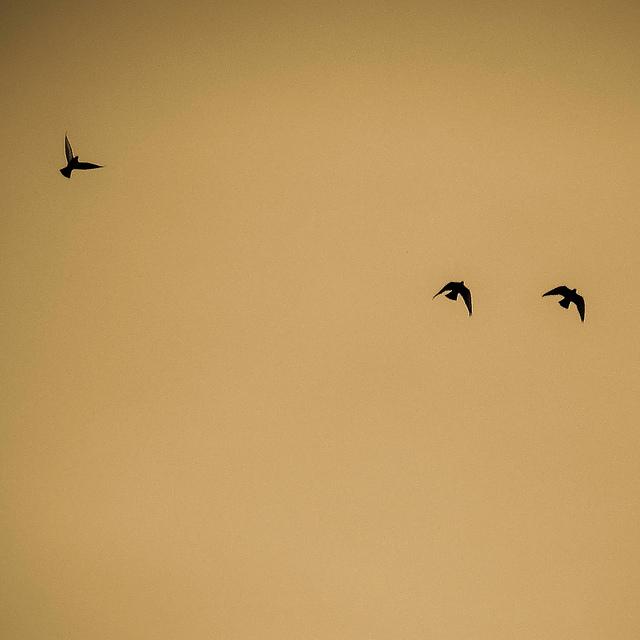What is flying in the air?
Answer briefly. Birds. How many birds are there?
Be succinct. 3. Are the birds wings open or closed?
Concise answer only. Open. Are there birds on the light post?
Concise answer only. No. Could this be synchronized flying?
Answer briefly. No. Is the bird flying?
Give a very brief answer. Yes. How many wings are there?
Write a very short answer. 6. Is there a bird in the picture?
Keep it brief. Yes. Is the sky blue?
Be succinct. No. What kind of bird is in flight?
Keep it brief. Pigeon. What color is the sky?
Quick response, please. Brown. What is this a picture of?
Give a very brief answer. Birds. What is the bird doing?
Quick response, please. Flying. Are these birds at the beach?
Be succinct. No. Are the birds wings in the same position?
Keep it brief. No. How many birds are flying?
Give a very brief answer. 3. What type of bird is in the photo?
Answer briefly. Hawk. Do these three, small objects, against the black setting, resemble a minimalist cartoon face?
Write a very short answer. No. How many birds?
Short answer required. 3. How does this bird's wingspan compare to that of a typical adult bald eagle?
Quick response, please. Smaller. What is pictured in the air?
Give a very brief answer. Birds. 